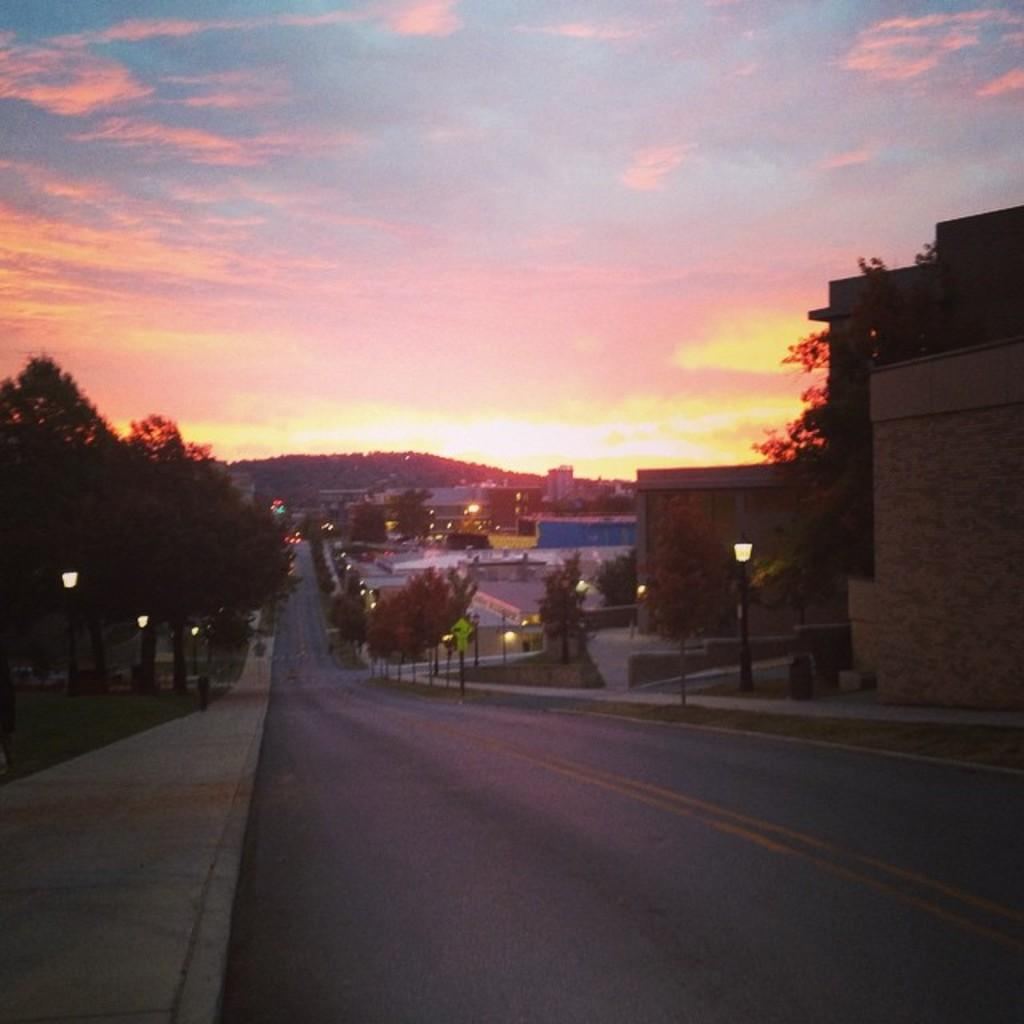What type of natural element can be seen in the image? There is a tree in the image. What structures are located on the left side of the image? There are light poles and a sidewalk on the left side of the image. What type of vegetation is present on the left side of the image? There are trees on the left side of the image. What type of man-made structures can be seen on the right side of the image? There are buildings on the right side of the image. What type of vegetation is present on the right side of the image? There are trees on the right side of the image. What type of lighting structures are present on the right side of the image? There are light poles on the right side of the image. What can be seen in the background of the image? The sky is visible in the background of the image. What type of tooth is being used to represent the tree in the image? There is no tooth present in the image, and the tree is not being represented by any tooth. How is the tooth being used in the image? There is no tooth present in the image, so it cannot be used for any purpose in the image. 